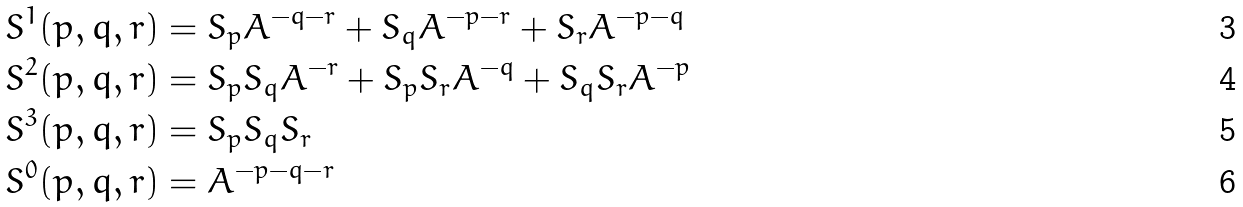<formula> <loc_0><loc_0><loc_500><loc_500>& S ^ { 1 } ( p , q , r ) = S _ { p } A ^ { - q - r } + S _ { q } A ^ { - p - r } + S _ { r } A ^ { - p - q } \\ & S ^ { 2 } ( p , q , r ) = S _ { p } S _ { q } A ^ { - r } + S _ { p } S _ { r } A ^ { - q } + S _ { q } S _ { r } A ^ { - p } \\ & S ^ { 3 } ( p , q , r ) = S _ { p } S _ { q } S _ { r } \\ & S ^ { 0 } ( p , q , r ) = A ^ { - p - q - r }</formula> 